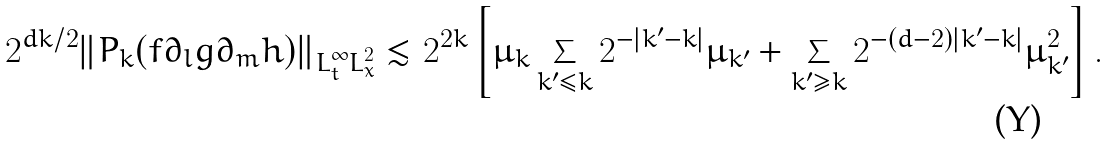<formula> <loc_0><loc_0><loc_500><loc_500>2 ^ { d k / 2 } \| P _ { k } ( f \partial _ { l } g \partial _ { m } h ) \| _ { L ^ { \infty } _ { t } L ^ { 2 } _ { x } } \lesssim 2 ^ { 2 k } \left [ \mu _ { k } \sum _ { k ^ { \prime } \leq k } 2 ^ { - | k ^ { \prime } - k | } \mu _ { k ^ { \prime } } + \sum _ { k ^ { \prime } \geq k } 2 ^ { - ( d - 2 ) | k ^ { \prime } - k | } \mu ^ { 2 } _ { k ^ { \prime } } \right ] .</formula> 